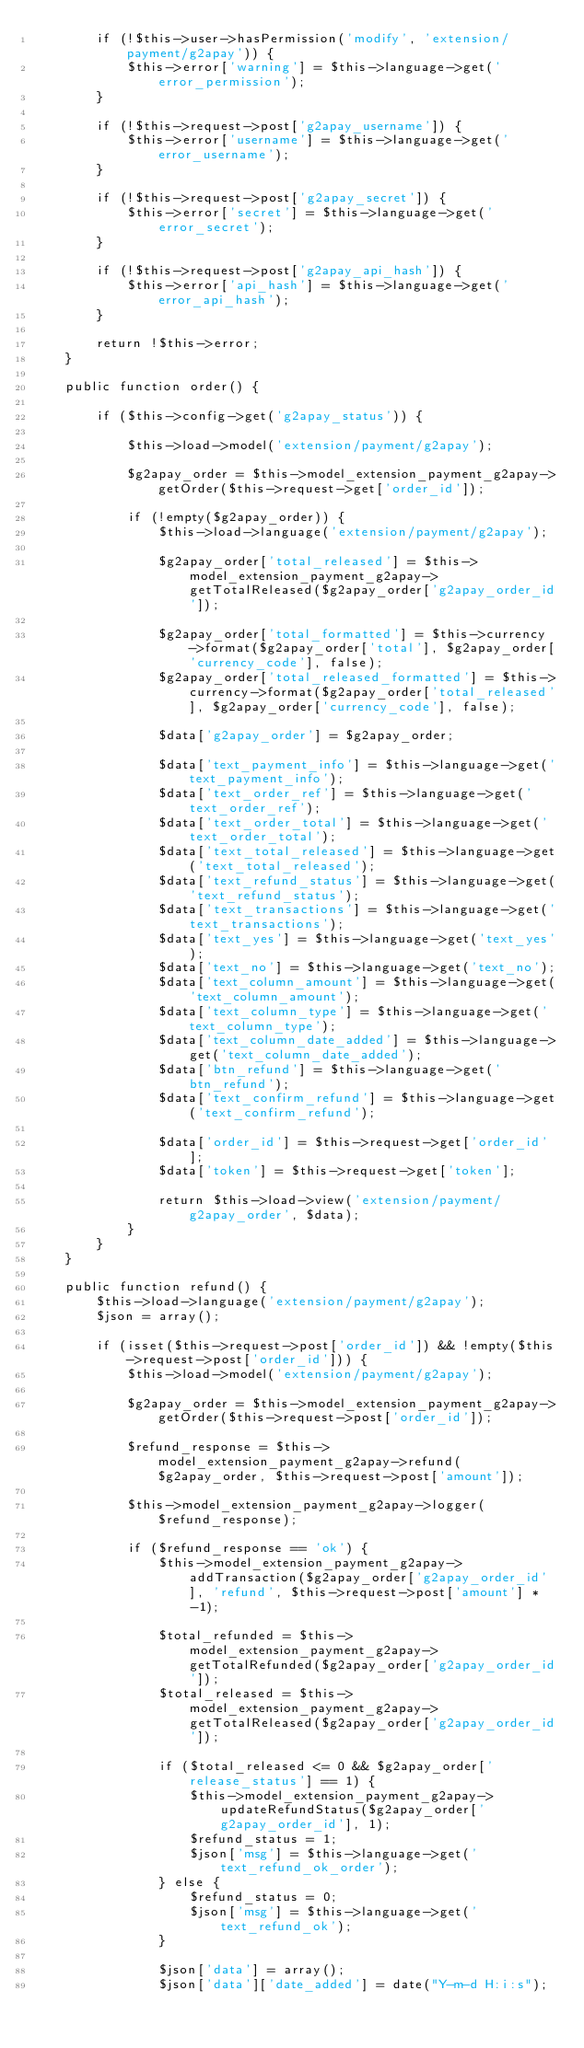Convert code to text. <code><loc_0><loc_0><loc_500><loc_500><_PHP_>        if (!$this->user->hasPermission('modify', 'extension/payment/g2apay')) {
            $this->error['warning'] = $this->language->get('error_permission');
        }

        if (!$this->request->post['g2apay_username']) {
            $this->error['username'] = $this->language->get('error_username');
        }

        if (!$this->request->post['g2apay_secret']) {
            $this->error['secret'] = $this->language->get('error_secret');
        }

        if (!$this->request->post['g2apay_api_hash']) {
            $this->error['api_hash'] = $this->language->get('error_api_hash');
        }

        return !$this->error;
    }

	public function order() {

		if ($this->config->get('g2apay_status')) {

			$this->load->model('extension/payment/g2apay');

			$g2apay_order = $this->model_extension_payment_g2apay->getOrder($this->request->get['order_id']);

			if (!empty($g2apay_order)) {
				$this->load->language('extension/payment/g2apay');

				$g2apay_order['total_released'] = $this->model_extension_payment_g2apay->getTotalReleased($g2apay_order['g2apay_order_id']);

				$g2apay_order['total_formatted'] = $this->currency->format($g2apay_order['total'], $g2apay_order['currency_code'], false);
				$g2apay_order['total_released_formatted'] = $this->currency->format($g2apay_order['total_released'], $g2apay_order['currency_code'], false);

				$data['g2apay_order'] = $g2apay_order;

				$data['text_payment_info'] = $this->language->get('text_payment_info');
				$data['text_order_ref'] = $this->language->get('text_order_ref');
				$data['text_order_total'] = $this->language->get('text_order_total');
				$data['text_total_released'] = $this->language->get('text_total_released');
				$data['text_refund_status'] = $this->language->get('text_refund_status');
				$data['text_transactions'] = $this->language->get('text_transactions');
				$data['text_yes'] = $this->language->get('text_yes');
				$data['text_no'] = $this->language->get('text_no');
				$data['text_column_amount'] = $this->language->get('text_column_amount');
				$data['text_column_type'] = $this->language->get('text_column_type');
				$data['text_column_date_added'] = $this->language->get('text_column_date_added');
				$data['btn_refund'] = $this->language->get('btn_refund');
				$data['text_confirm_refund'] = $this->language->get('text_confirm_refund');

				$data['order_id'] = $this->request->get['order_id'];
				$data['token'] = $this->request->get['token'];

				return $this->load->view('extension/payment/g2apay_order', $data);
			}
		}
	}

	public function refund() {
		$this->load->language('extension/payment/g2apay');
		$json = array();

		if (isset($this->request->post['order_id']) && !empty($this->request->post['order_id'])) {
			$this->load->model('extension/payment/g2apay');

			$g2apay_order = $this->model_extension_payment_g2apay->getOrder($this->request->post['order_id']);

			$refund_response = $this->model_extension_payment_g2apay->refund($g2apay_order, $this->request->post['amount']);

			$this->model_extension_payment_g2apay->logger($refund_response);

			if ($refund_response == 'ok') {
				$this->model_extension_payment_g2apay->addTransaction($g2apay_order['g2apay_order_id'], 'refund', $this->request->post['amount'] * -1);

				$total_refunded = $this->model_extension_payment_g2apay->getTotalRefunded($g2apay_order['g2apay_order_id']);
				$total_released = $this->model_extension_payment_g2apay->getTotalReleased($g2apay_order['g2apay_order_id']);

				if ($total_released <= 0 && $g2apay_order['release_status'] == 1) {
					$this->model_extension_payment_g2apay->updateRefundStatus($g2apay_order['g2apay_order_id'], 1);
					$refund_status = 1;
					$json['msg'] = $this->language->get('text_refund_ok_order');
				} else {
					$refund_status = 0;
					$json['msg'] = $this->language->get('text_refund_ok');
				}

				$json['data'] = array();
				$json['data']['date_added'] = date("Y-m-d H:i:s");</code> 